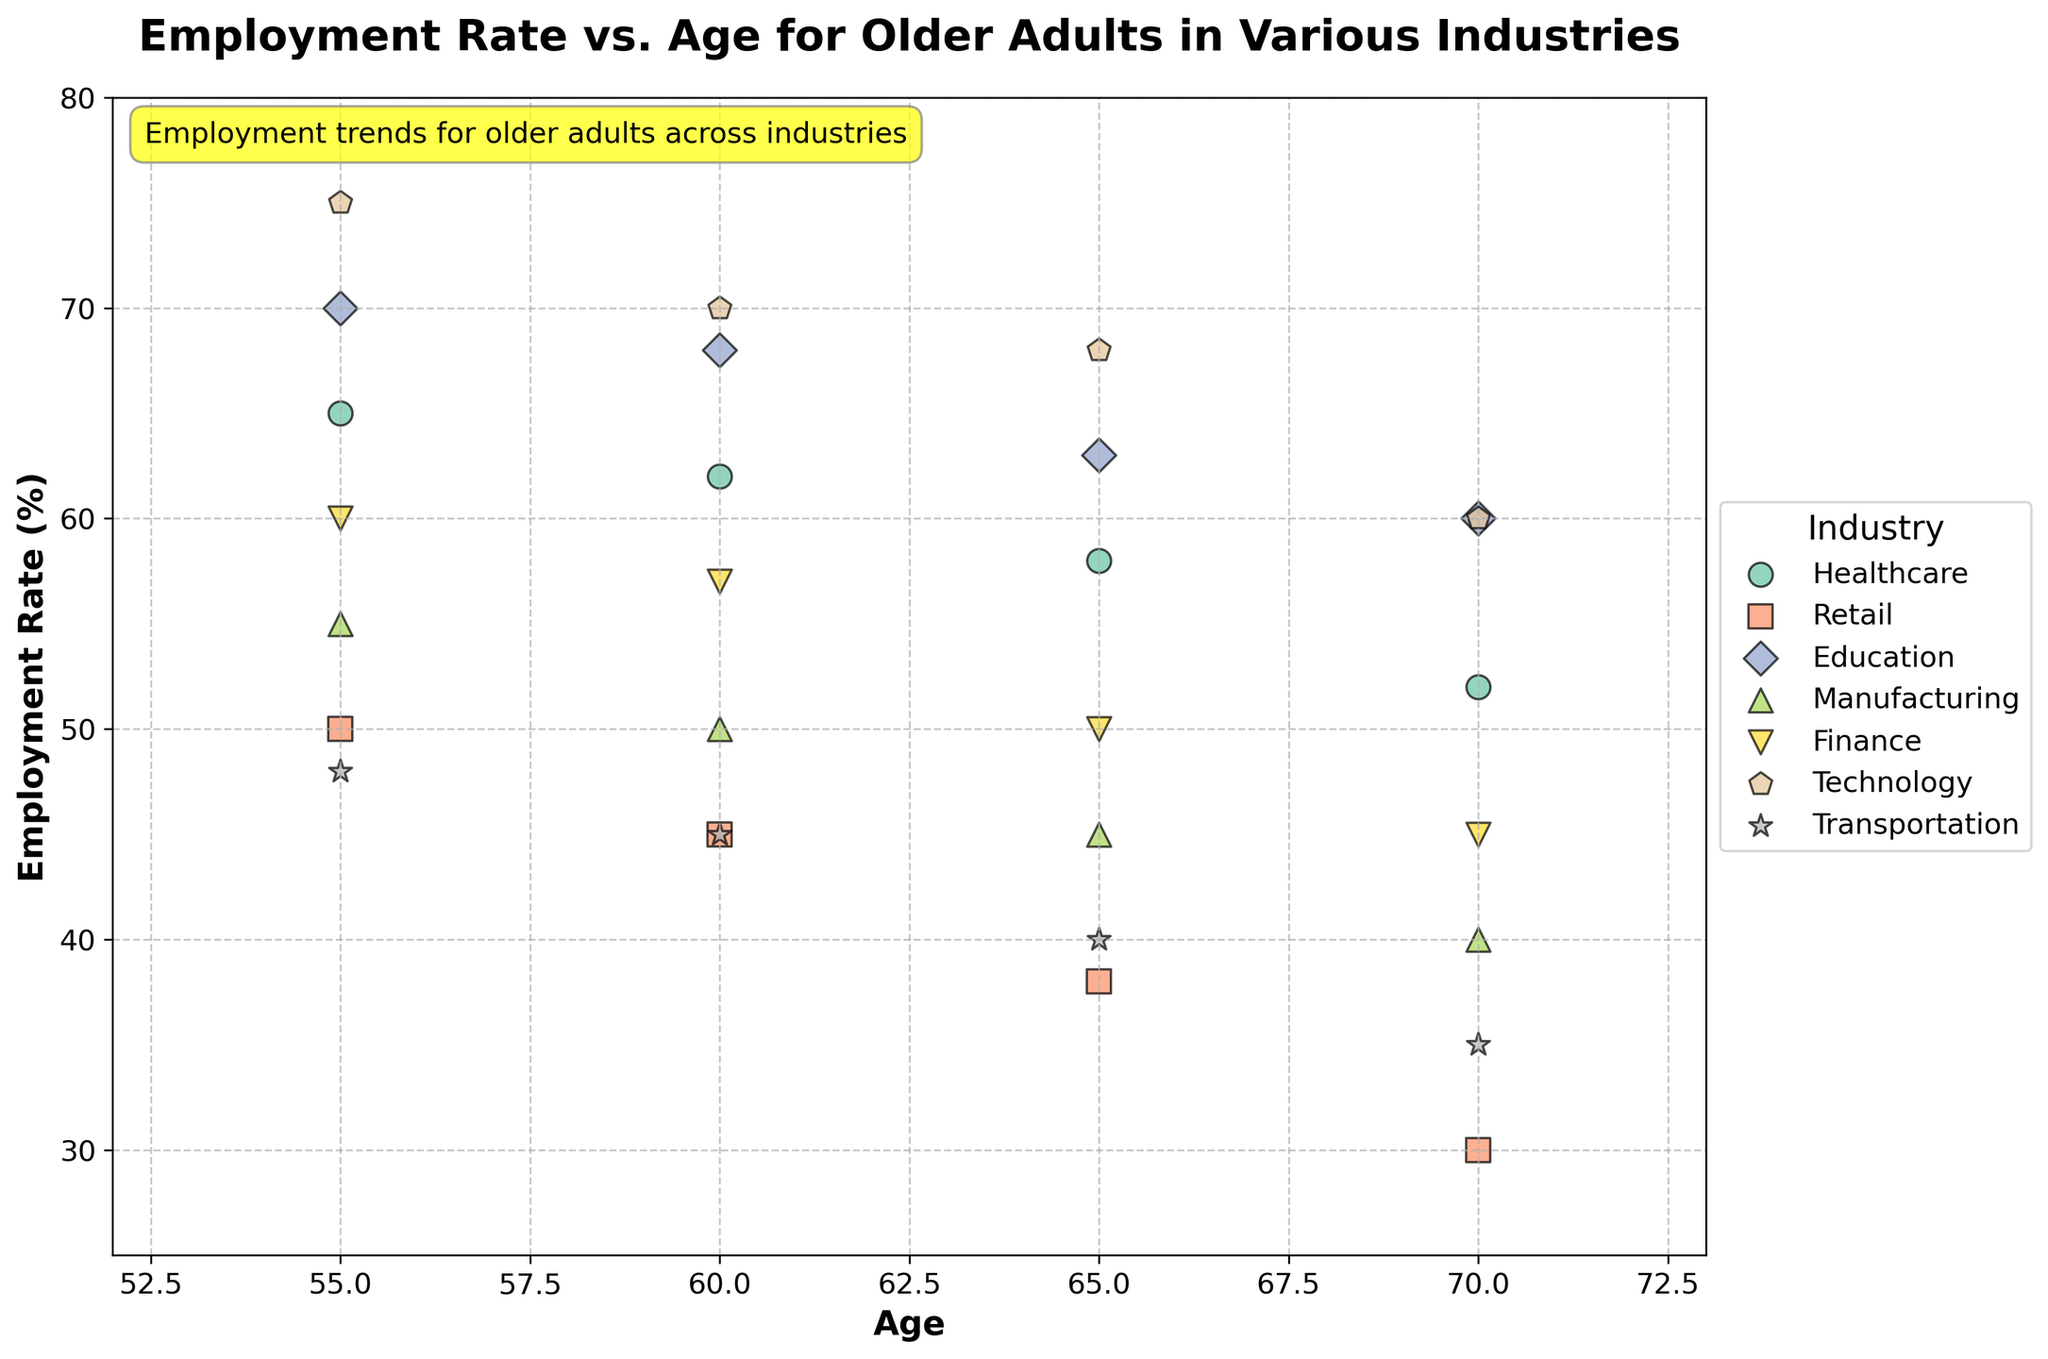What is the title of the figure? The title is typically found at the top of the plot and provides a summary of what the figure depicts. Here, it's positioned prominently to draw attention to the context of the data.
Answer: Employment Rate vs. Age for Older Adults in Various Industries Which industry has the highest employment rate for the 60-year-old age group? By looking at the data points for the different industries at the age of 60, we determine which one has the highest employment rate.
Answer: Technology How does the employment rate change with age in the Healthcare industry? By examining the trend of the data points for the Healthcare industry, specifically the movement from age 55 to 70, we can see how the employment rate increases or decreases.
Answer: It decreases Which two industries have the most similar employment rates for 65-year-olds? Compare the employment rates at age 65 for all industries to find the two with the closest values.
Answer: Technology and Education What is the average employment rate for 55-year-olds across all industries? Calculate the employment rates for 55-year-olds in each industry, then find the mean of these values.
Answer: (65+50+70+55+60+75+48) / 7 = 60.43 Which industry shows the highest drop in employment rate from age 55 to 70? Evaluate the difference in employment rate from 55 to 70 for each industry and identify the one with the largest decline.
Answer: Retail What can you infer about the employment trend in the Technology industry as people age from 55 to 70? Look at the scatter points in the Technology industry and describe the pattern of employment rate from age 55 to age 70.
Answer: The employment rate slightly decreases Between the Finance and Manufacturing industries, which shows a higher employment rate for 60-year-olds? Evaluate the employment rate for 60-year-olds in both the Finance and Manufacturing industries and compare them.
Answer: Finance Which industry has the most significant variation in employment rates as people age? Compare the range of employment rates for each industry by observing the spread of the data points across ages 55 to 70.
Answer: Retail Does the Education industry maintain a high employment rate for older adults compared to other industries? Observe the employment rates at different ages for the Education industry and compare them with other industries to determine if it remains consistently high.
Answer: Yes 